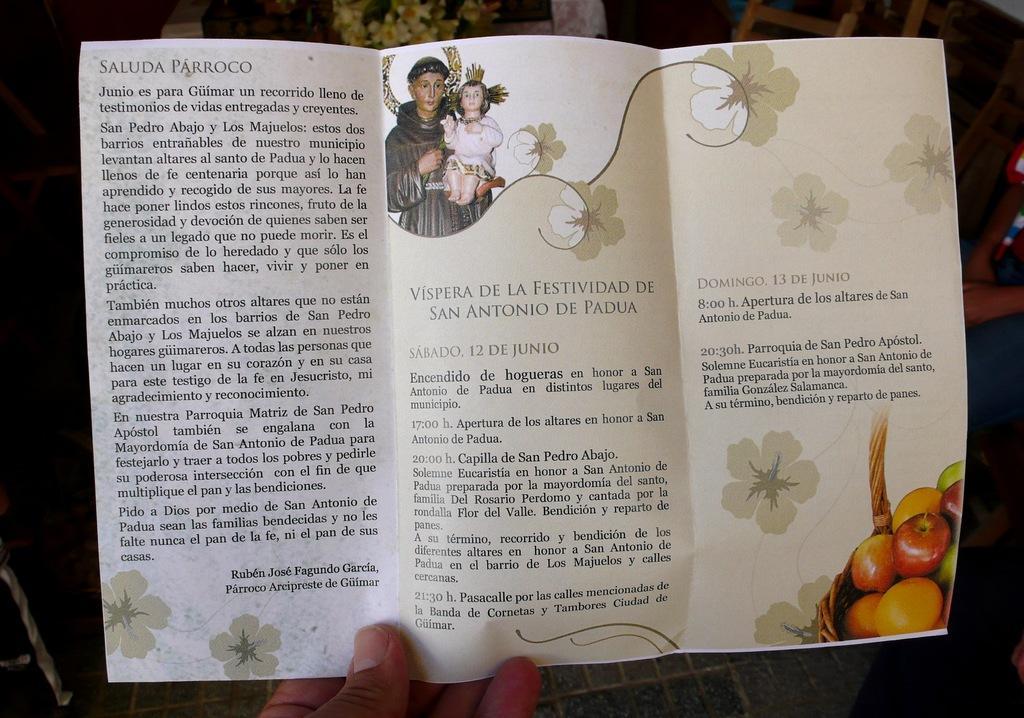Could you give a brief overview of what you see in this image? In this picture there is a person holding a brochure which has two pictures and something written on it and there are some other objects in the background. 